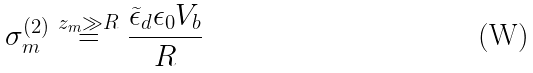Convert formula to latex. <formula><loc_0><loc_0><loc_500><loc_500>\sigma _ { m } ^ { ( 2 ) } \overset { z _ { m } \gg R } { = } \frac { \widetilde { \epsilon } _ { d } \epsilon _ { 0 } V _ { b } } { R }</formula> 